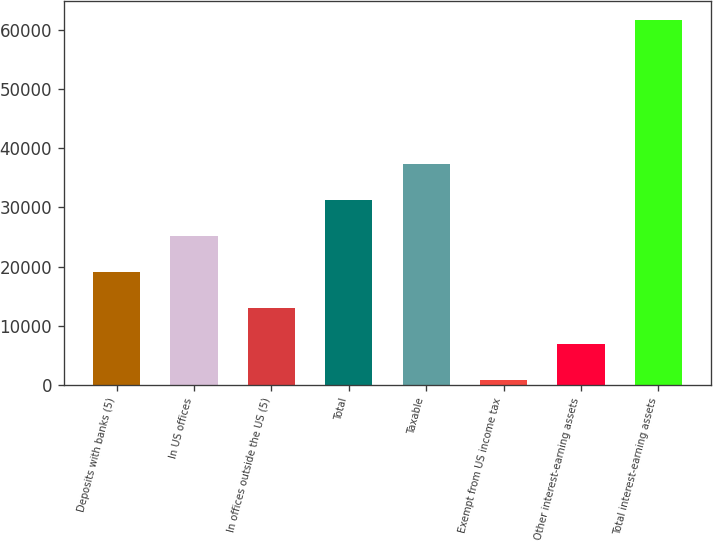Convert chart to OTSL. <chart><loc_0><loc_0><loc_500><loc_500><bar_chart><fcel>Deposits with banks (5)<fcel>In US offices<fcel>In offices outside the US (5)<fcel>Total<fcel>Taxable<fcel>Exempt from US income tax<fcel>Other interest-earning assets<fcel>Total interest-earning assets<nl><fcel>19052.5<fcel>25145<fcel>12960<fcel>31237.5<fcel>37330<fcel>775<fcel>6867.5<fcel>61700<nl></chart> 